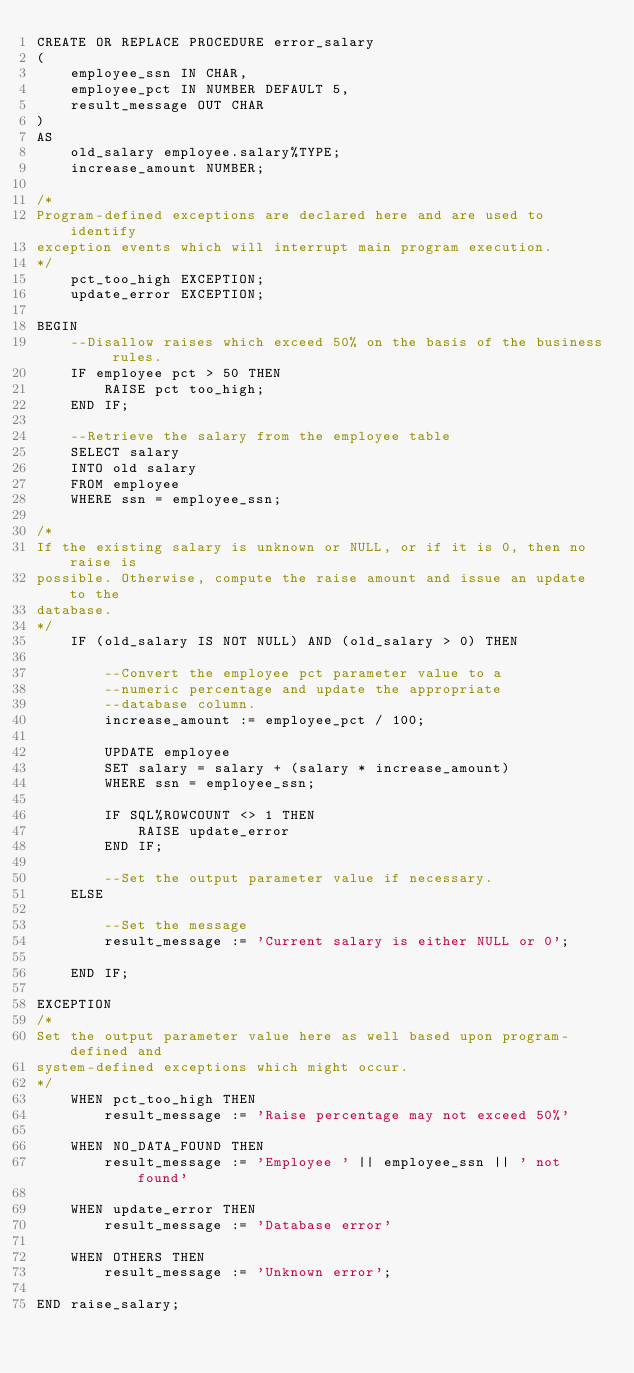<code> <loc_0><loc_0><loc_500><loc_500><_SQL_>CREATE OR REPLACE PROCEDURE error_salary 
( 
	employee_ssn IN CHAR, 
	employee_pct IN NUMBER DEFAULT 5, 
	result_message OUT CHAR 
) 
AS 
	old_salary employee.salary%TYPE; 
	increase_amount NUMBER; 

/* 
Program-defined exceptions are declared here and are used to identify 
exception events which will interrupt main program execution. 
*/ 
	pct_too_high EXCEPTION;
	update_error EXCEPTION;

BEGIN 
	--Disallow raises which exceed 50% on the basis of the business rules. 
	IF employee pct > 50 THEN 
		RAISE pct too_high; 
	END IF; 

	--Retrieve the salary from the employee table
	SELECT salary 
	INTO old salary 
	FROM employee 
	WHERE ssn = employee_ssn; 

/* 
If the existing salary is unknown or NULL, or if it is 0, then no raise is 
possible. Otherwise, compute the raise amount and issue an update to the 
database. 
*/ 
	IF (old_salary IS NOT NULL) AND (old_salary > 0) THEN

		--Convert the employee pct parameter value to a 
		--numeric percentage and update the appropriate 
		--database column. 
		increase_amount := employee_pct / 100; 

		UPDATE employee 
		SET salary = salary + (salary * increase_amount) 
		WHERE ssn = employee_ssn; 
		
		IF SQL%ROWCOUNT <> 1 THEN 
			RAISE update_error
		END IF; 

		--Set the output parameter value if necessary. 
	ELSE
	
		--Set the message
		result_message := 'Current salary is either NULL or 0';

	END IF;
	
EXCEPTION
/*
Set the output parameter value here as well based upon program-defined and
system-defined exceptions which might occur.
*/
	WHEN pct_too_high THEN
		result_message := 'Raise percentage may not exceed 50%'
		
	WHEN NO_DATA_FOUND THEN
		result_message := 'Employee ' || employee_ssn || ' not found'
	
	WHEN update_error THEN
		result_message := 'Database error'
	
	WHEN OTHERS THEN
		result_message := 'Unknown error';

END raise_salary;</code> 